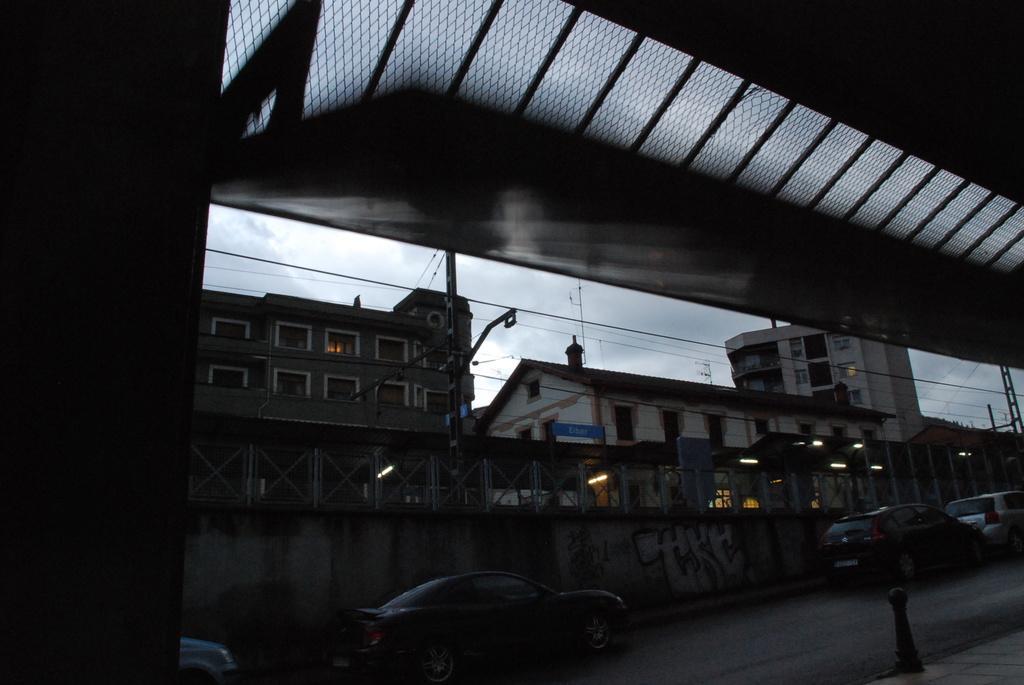Describe this image in one or two sentences. In this image I can see the bridge. To the side of the bridge I can see the vehicles on the road. In the background I can see the fence, many buildings, lights and the sky. 